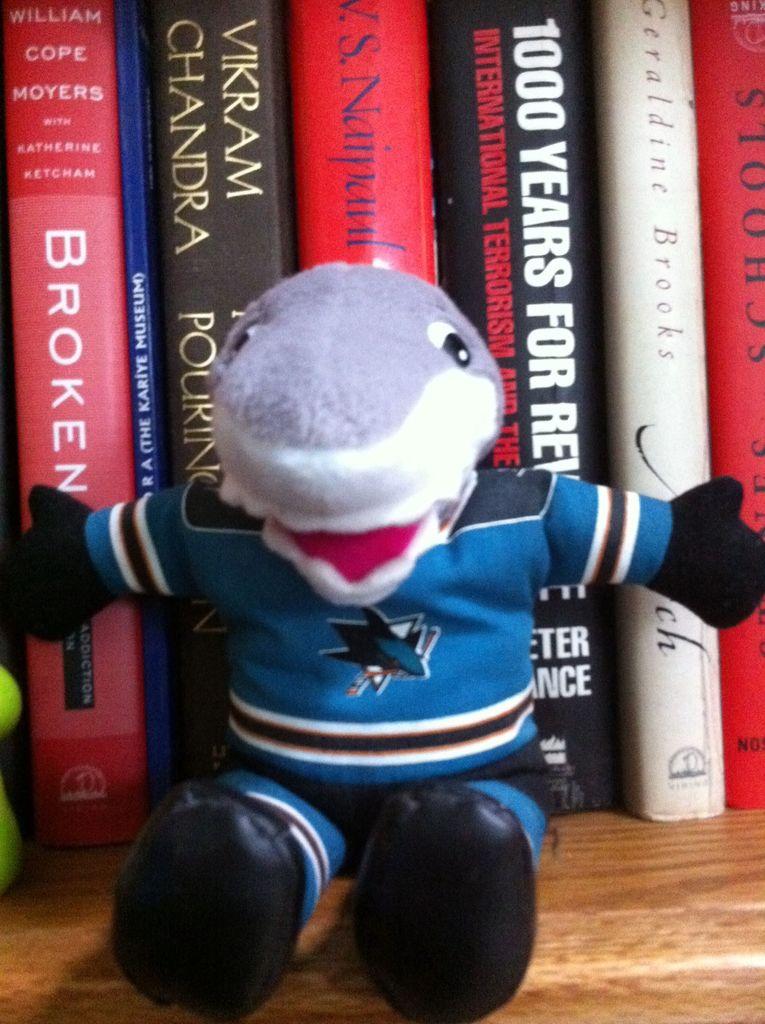Who's name is written on the book to the far left?
Offer a very short reply. William cope moyers. How many years is on the black book?
Keep it short and to the point. 1000. 